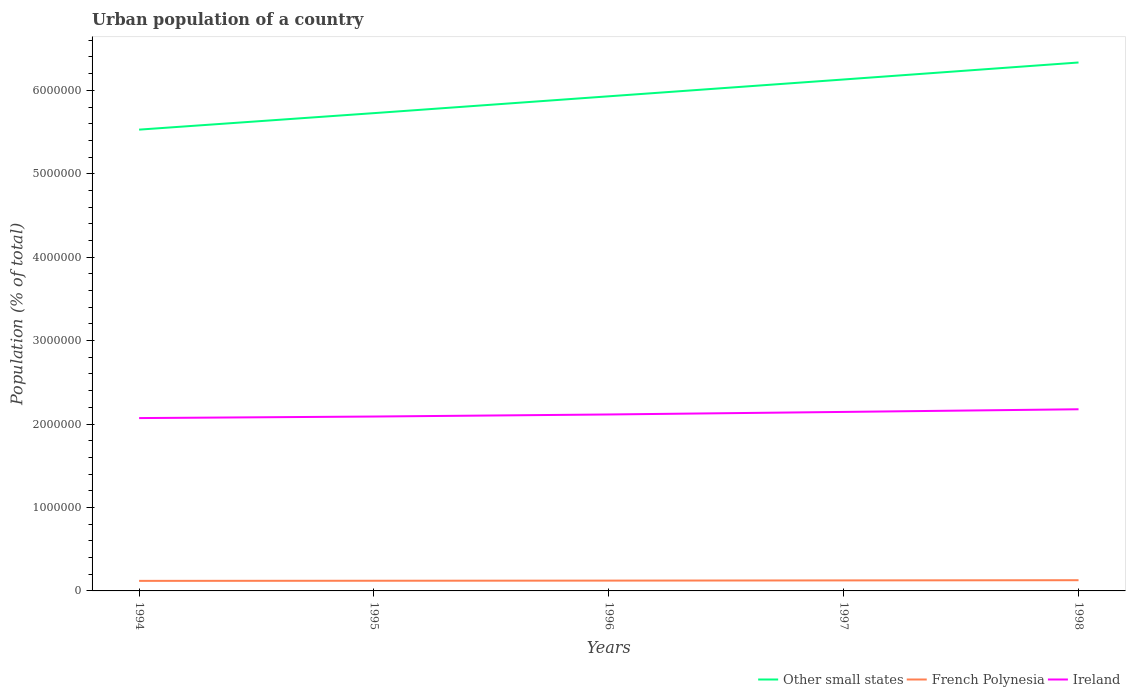Does the line corresponding to Ireland intersect with the line corresponding to French Polynesia?
Provide a succinct answer. No. Across all years, what is the maximum urban population in Other small states?
Provide a succinct answer. 5.53e+06. In which year was the urban population in Other small states maximum?
Give a very brief answer. 1994. What is the total urban population in Ireland in the graph?
Your response must be concise. -2.48e+04. What is the difference between the highest and the second highest urban population in French Polynesia?
Give a very brief answer. 8033. Is the urban population in Other small states strictly greater than the urban population in Ireland over the years?
Your response must be concise. No. How many lines are there?
Offer a terse response. 3. How many years are there in the graph?
Your answer should be compact. 5. What is the difference between two consecutive major ticks on the Y-axis?
Make the answer very short. 1.00e+06. Does the graph contain grids?
Give a very brief answer. No. How many legend labels are there?
Provide a short and direct response. 3. What is the title of the graph?
Give a very brief answer. Urban population of a country. Does "American Samoa" appear as one of the legend labels in the graph?
Your answer should be very brief. No. What is the label or title of the X-axis?
Make the answer very short. Years. What is the label or title of the Y-axis?
Provide a short and direct response. Population (% of total). What is the Population (% of total) in Other small states in 1994?
Offer a terse response. 5.53e+06. What is the Population (% of total) of French Polynesia in 1994?
Your response must be concise. 1.20e+05. What is the Population (% of total) of Ireland in 1994?
Give a very brief answer. 2.07e+06. What is the Population (% of total) in Other small states in 1995?
Keep it short and to the point. 5.73e+06. What is the Population (% of total) in French Polynesia in 1995?
Give a very brief answer. 1.22e+05. What is the Population (% of total) in Ireland in 1995?
Offer a very short reply. 2.09e+06. What is the Population (% of total) in Other small states in 1996?
Your answer should be compact. 5.93e+06. What is the Population (% of total) in French Polynesia in 1996?
Your answer should be compact. 1.24e+05. What is the Population (% of total) of Ireland in 1996?
Your answer should be compact. 2.11e+06. What is the Population (% of total) in Other small states in 1997?
Offer a very short reply. 6.13e+06. What is the Population (% of total) of French Polynesia in 1997?
Keep it short and to the point. 1.26e+05. What is the Population (% of total) of Ireland in 1997?
Offer a terse response. 2.15e+06. What is the Population (% of total) of Other small states in 1998?
Give a very brief answer. 6.33e+06. What is the Population (% of total) in French Polynesia in 1998?
Keep it short and to the point. 1.28e+05. What is the Population (% of total) in Ireland in 1998?
Your answer should be very brief. 2.18e+06. Across all years, what is the maximum Population (% of total) of Other small states?
Offer a terse response. 6.33e+06. Across all years, what is the maximum Population (% of total) of French Polynesia?
Provide a succinct answer. 1.28e+05. Across all years, what is the maximum Population (% of total) in Ireland?
Ensure brevity in your answer.  2.18e+06. Across all years, what is the minimum Population (% of total) in Other small states?
Provide a short and direct response. 5.53e+06. Across all years, what is the minimum Population (% of total) of French Polynesia?
Provide a succinct answer. 1.20e+05. Across all years, what is the minimum Population (% of total) of Ireland?
Offer a terse response. 2.07e+06. What is the total Population (% of total) in Other small states in the graph?
Provide a succinct answer. 2.96e+07. What is the total Population (% of total) in French Polynesia in the graph?
Give a very brief answer. 6.20e+05. What is the total Population (% of total) of Ireland in the graph?
Offer a very short reply. 1.06e+07. What is the difference between the Population (% of total) of Other small states in 1994 and that in 1995?
Your answer should be compact. -1.98e+05. What is the difference between the Population (% of total) of French Polynesia in 1994 and that in 1995?
Offer a very short reply. -1530. What is the difference between the Population (% of total) of Ireland in 1994 and that in 1995?
Ensure brevity in your answer.  -1.85e+04. What is the difference between the Population (% of total) in Other small states in 1994 and that in 1996?
Your answer should be very brief. -4.00e+05. What is the difference between the Population (% of total) of French Polynesia in 1994 and that in 1996?
Give a very brief answer. -3305. What is the difference between the Population (% of total) in Ireland in 1994 and that in 1996?
Provide a succinct answer. -4.33e+04. What is the difference between the Population (% of total) in Other small states in 1994 and that in 1997?
Provide a succinct answer. -6.01e+05. What is the difference between the Population (% of total) of French Polynesia in 1994 and that in 1997?
Ensure brevity in your answer.  -5585. What is the difference between the Population (% of total) of Ireland in 1994 and that in 1997?
Provide a succinct answer. -7.38e+04. What is the difference between the Population (% of total) in Other small states in 1994 and that in 1998?
Your response must be concise. -8.05e+05. What is the difference between the Population (% of total) in French Polynesia in 1994 and that in 1998?
Your response must be concise. -8033. What is the difference between the Population (% of total) of Ireland in 1994 and that in 1998?
Offer a very short reply. -1.06e+05. What is the difference between the Population (% of total) in Other small states in 1995 and that in 1996?
Your response must be concise. -2.02e+05. What is the difference between the Population (% of total) of French Polynesia in 1995 and that in 1996?
Your answer should be very brief. -1775. What is the difference between the Population (% of total) in Ireland in 1995 and that in 1996?
Your response must be concise. -2.48e+04. What is the difference between the Population (% of total) in Other small states in 1995 and that in 1997?
Your answer should be very brief. -4.03e+05. What is the difference between the Population (% of total) of French Polynesia in 1995 and that in 1997?
Offer a very short reply. -4055. What is the difference between the Population (% of total) in Ireland in 1995 and that in 1997?
Give a very brief answer. -5.53e+04. What is the difference between the Population (% of total) in Other small states in 1995 and that in 1998?
Make the answer very short. -6.07e+05. What is the difference between the Population (% of total) of French Polynesia in 1995 and that in 1998?
Your response must be concise. -6503. What is the difference between the Population (% of total) in Ireland in 1995 and that in 1998?
Keep it short and to the point. -8.71e+04. What is the difference between the Population (% of total) in Other small states in 1996 and that in 1997?
Your response must be concise. -2.01e+05. What is the difference between the Population (% of total) in French Polynesia in 1996 and that in 1997?
Provide a succinct answer. -2280. What is the difference between the Population (% of total) in Ireland in 1996 and that in 1997?
Offer a very short reply. -3.05e+04. What is the difference between the Population (% of total) of Other small states in 1996 and that in 1998?
Offer a very short reply. -4.05e+05. What is the difference between the Population (% of total) of French Polynesia in 1996 and that in 1998?
Give a very brief answer. -4728. What is the difference between the Population (% of total) in Ireland in 1996 and that in 1998?
Provide a succinct answer. -6.23e+04. What is the difference between the Population (% of total) in Other small states in 1997 and that in 1998?
Provide a succinct answer. -2.04e+05. What is the difference between the Population (% of total) in French Polynesia in 1997 and that in 1998?
Your answer should be very brief. -2448. What is the difference between the Population (% of total) of Ireland in 1997 and that in 1998?
Your answer should be very brief. -3.18e+04. What is the difference between the Population (% of total) of Other small states in 1994 and the Population (% of total) of French Polynesia in 1995?
Offer a terse response. 5.41e+06. What is the difference between the Population (% of total) of Other small states in 1994 and the Population (% of total) of Ireland in 1995?
Your response must be concise. 3.44e+06. What is the difference between the Population (% of total) in French Polynesia in 1994 and the Population (% of total) in Ireland in 1995?
Offer a terse response. -1.97e+06. What is the difference between the Population (% of total) of Other small states in 1994 and the Population (% of total) of French Polynesia in 1996?
Provide a short and direct response. 5.41e+06. What is the difference between the Population (% of total) of Other small states in 1994 and the Population (% of total) of Ireland in 1996?
Keep it short and to the point. 3.41e+06. What is the difference between the Population (% of total) of French Polynesia in 1994 and the Population (% of total) of Ireland in 1996?
Provide a short and direct response. -1.99e+06. What is the difference between the Population (% of total) in Other small states in 1994 and the Population (% of total) in French Polynesia in 1997?
Offer a terse response. 5.40e+06. What is the difference between the Population (% of total) of Other small states in 1994 and the Population (% of total) of Ireland in 1997?
Offer a terse response. 3.38e+06. What is the difference between the Population (% of total) in French Polynesia in 1994 and the Population (% of total) in Ireland in 1997?
Your answer should be compact. -2.03e+06. What is the difference between the Population (% of total) of Other small states in 1994 and the Population (% of total) of French Polynesia in 1998?
Your answer should be very brief. 5.40e+06. What is the difference between the Population (% of total) of Other small states in 1994 and the Population (% of total) of Ireland in 1998?
Ensure brevity in your answer.  3.35e+06. What is the difference between the Population (% of total) in French Polynesia in 1994 and the Population (% of total) in Ireland in 1998?
Offer a very short reply. -2.06e+06. What is the difference between the Population (% of total) in Other small states in 1995 and the Population (% of total) in French Polynesia in 1996?
Your response must be concise. 5.60e+06. What is the difference between the Population (% of total) of Other small states in 1995 and the Population (% of total) of Ireland in 1996?
Your answer should be compact. 3.61e+06. What is the difference between the Population (% of total) in French Polynesia in 1995 and the Population (% of total) in Ireland in 1996?
Offer a very short reply. -1.99e+06. What is the difference between the Population (% of total) of Other small states in 1995 and the Population (% of total) of French Polynesia in 1997?
Your answer should be compact. 5.60e+06. What is the difference between the Population (% of total) of Other small states in 1995 and the Population (% of total) of Ireland in 1997?
Give a very brief answer. 3.58e+06. What is the difference between the Population (% of total) in French Polynesia in 1995 and the Population (% of total) in Ireland in 1997?
Ensure brevity in your answer.  -2.02e+06. What is the difference between the Population (% of total) in Other small states in 1995 and the Population (% of total) in French Polynesia in 1998?
Make the answer very short. 5.60e+06. What is the difference between the Population (% of total) of Other small states in 1995 and the Population (% of total) of Ireland in 1998?
Make the answer very short. 3.55e+06. What is the difference between the Population (% of total) in French Polynesia in 1995 and the Population (% of total) in Ireland in 1998?
Provide a short and direct response. -2.06e+06. What is the difference between the Population (% of total) of Other small states in 1996 and the Population (% of total) of French Polynesia in 1997?
Your answer should be compact. 5.80e+06. What is the difference between the Population (% of total) in Other small states in 1996 and the Population (% of total) in Ireland in 1997?
Your answer should be compact. 3.78e+06. What is the difference between the Population (% of total) of French Polynesia in 1996 and the Population (% of total) of Ireland in 1997?
Your answer should be very brief. -2.02e+06. What is the difference between the Population (% of total) of Other small states in 1996 and the Population (% of total) of French Polynesia in 1998?
Offer a terse response. 5.80e+06. What is the difference between the Population (% of total) of Other small states in 1996 and the Population (% of total) of Ireland in 1998?
Offer a very short reply. 3.75e+06. What is the difference between the Population (% of total) of French Polynesia in 1996 and the Population (% of total) of Ireland in 1998?
Ensure brevity in your answer.  -2.05e+06. What is the difference between the Population (% of total) of Other small states in 1997 and the Population (% of total) of French Polynesia in 1998?
Your response must be concise. 6.00e+06. What is the difference between the Population (% of total) in Other small states in 1997 and the Population (% of total) in Ireland in 1998?
Offer a terse response. 3.95e+06. What is the difference between the Population (% of total) in French Polynesia in 1997 and the Population (% of total) in Ireland in 1998?
Provide a short and direct response. -2.05e+06. What is the average Population (% of total) of Other small states per year?
Make the answer very short. 5.93e+06. What is the average Population (% of total) of French Polynesia per year?
Ensure brevity in your answer.  1.24e+05. What is the average Population (% of total) in Ireland per year?
Provide a short and direct response. 2.12e+06. In the year 1994, what is the difference between the Population (% of total) of Other small states and Population (% of total) of French Polynesia?
Keep it short and to the point. 5.41e+06. In the year 1994, what is the difference between the Population (% of total) in Other small states and Population (% of total) in Ireland?
Your answer should be very brief. 3.46e+06. In the year 1994, what is the difference between the Population (% of total) of French Polynesia and Population (% of total) of Ireland?
Make the answer very short. -1.95e+06. In the year 1995, what is the difference between the Population (% of total) in Other small states and Population (% of total) in French Polynesia?
Your answer should be very brief. 5.60e+06. In the year 1995, what is the difference between the Population (% of total) in Other small states and Population (% of total) in Ireland?
Provide a succinct answer. 3.64e+06. In the year 1995, what is the difference between the Population (% of total) of French Polynesia and Population (% of total) of Ireland?
Your answer should be compact. -1.97e+06. In the year 1996, what is the difference between the Population (% of total) in Other small states and Population (% of total) in French Polynesia?
Offer a very short reply. 5.80e+06. In the year 1996, what is the difference between the Population (% of total) of Other small states and Population (% of total) of Ireland?
Your answer should be very brief. 3.81e+06. In the year 1996, what is the difference between the Population (% of total) in French Polynesia and Population (% of total) in Ireland?
Ensure brevity in your answer.  -1.99e+06. In the year 1997, what is the difference between the Population (% of total) of Other small states and Population (% of total) of French Polynesia?
Make the answer very short. 6.00e+06. In the year 1997, what is the difference between the Population (% of total) in Other small states and Population (% of total) in Ireland?
Keep it short and to the point. 3.98e+06. In the year 1997, what is the difference between the Population (% of total) of French Polynesia and Population (% of total) of Ireland?
Offer a very short reply. -2.02e+06. In the year 1998, what is the difference between the Population (% of total) of Other small states and Population (% of total) of French Polynesia?
Your response must be concise. 6.21e+06. In the year 1998, what is the difference between the Population (% of total) in Other small states and Population (% of total) in Ireland?
Your answer should be very brief. 4.16e+06. In the year 1998, what is the difference between the Population (% of total) of French Polynesia and Population (% of total) of Ireland?
Your answer should be very brief. -2.05e+06. What is the ratio of the Population (% of total) in Other small states in 1994 to that in 1995?
Keep it short and to the point. 0.97. What is the ratio of the Population (% of total) of French Polynesia in 1994 to that in 1995?
Give a very brief answer. 0.99. What is the ratio of the Population (% of total) in Ireland in 1994 to that in 1995?
Provide a succinct answer. 0.99. What is the ratio of the Population (% of total) of Other small states in 1994 to that in 1996?
Give a very brief answer. 0.93. What is the ratio of the Population (% of total) in French Polynesia in 1994 to that in 1996?
Provide a succinct answer. 0.97. What is the ratio of the Population (% of total) of Ireland in 1994 to that in 1996?
Provide a succinct answer. 0.98. What is the ratio of the Population (% of total) of Other small states in 1994 to that in 1997?
Make the answer very short. 0.9. What is the ratio of the Population (% of total) in French Polynesia in 1994 to that in 1997?
Keep it short and to the point. 0.96. What is the ratio of the Population (% of total) of Ireland in 1994 to that in 1997?
Keep it short and to the point. 0.97. What is the ratio of the Population (% of total) in Other small states in 1994 to that in 1998?
Provide a short and direct response. 0.87. What is the ratio of the Population (% of total) in French Polynesia in 1994 to that in 1998?
Your response must be concise. 0.94. What is the ratio of the Population (% of total) in Ireland in 1994 to that in 1998?
Offer a very short reply. 0.95. What is the ratio of the Population (% of total) of Other small states in 1995 to that in 1996?
Provide a short and direct response. 0.97. What is the ratio of the Population (% of total) of French Polynesia in 1995 to that in 1996?
Make the answer very short. 0.99. What is the ratio of the Population (% of total) in Ireland in 1995 to that in 1996?
Provide a short and direct response. 0.99. What is the ratio of the Population (% of total) in Other small states in 1995 to that in 1997?
Offer a very short reply. 0.93. What is the ratio of the Population (% of total) of French Polynesia in 1995 to that in 1997?
Give a very brief answer. 0.97. What is the ratio of the Population (% of total) in Ireland in 1995 to that in 1997?
Your response must be concise. 0.97. What is the ratio of the Population (% of total) of Other small states in 1995 to that in 1998?
Your answer should be very brief. 0.9. What is the ratio of the Population (% of total) of French Polynesia in 1995 to that in 1998?
Offer a very short reply. 0.95. What is the ratio of the Population (% of total) of Other small states in 1996 to that in 1997?
Offer a very short reply. 0.97. What is the ratio of the Population (% of total) of French Polynesia in 1996 to that in 1997?
Keep it short and to the point. 0.98. What is the ratio of the Population (% of total) of Ireland in 1996 to that in 1997?
Give a very brief answer. 0.99. What is the ratio of the Population (% of total) of Other small states in 1996 to that in 1998?
Your answer should be compact. 0.94. What is the ratio of the Population (% of total) of French Polynesia in 1996 to that in 1998?
Keep it short and to the point. 0.96. What is the ratio of the Population (% of total) of Ireland in 1996 to that in 1998?
Make the answer very short. 0.97. What is the ratio of the Population (% of total) of Other small states in 1997 to that in 1998?
Your response must be concise. 0.97. What is the ratio of the Population (% of total) of French Polynesia in 1997 to that in 1998?
Your answer should be compact. 0.98. What is the ratio of the Population (% of total) in Ireland in 1997 to that in 1998?
Provide a succinct answer. 0.99. What is the difference between the highest and the second highest Population (% of total) of Other small states?
Give a very brief answer. 2.04e+05. What is the difference between the highest and the second highest Population (% of total) of French Polynesia?
Your answer should be compact. 2448. What is the difference between the highest and the second highest Population (% of total) in Ireland?
Offer a terse response. 3.18e+04. What is the difference between the highest and the lowest Population (% of total) in Other small states?
Provide a succinct answer. 8.05e+05. What is the difference between the highest and the lowest Population (% of total) in French Polynesia?
Give a very brief answer. 8033. What is the difference between the highest and the lowest Population (% of total) in Ireland?
Provide a succinct answer. 1.06e+05. 